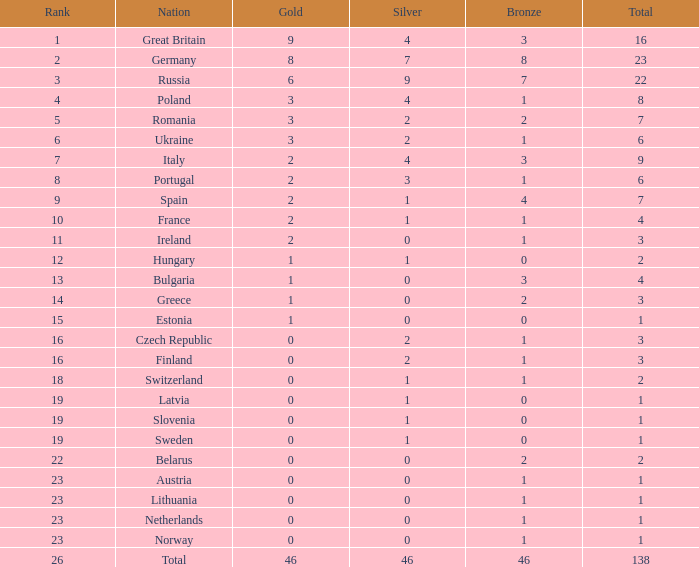Can you parse all the data within this table? {'header': ['Rank', 'Nation', 'Gold', 'Silver', 'Bronze', 'Total'], 'rows': [['1', 'Great Britain', '9', '4', '3', '16'], ['2', 'Germany', '8', '7', '8', '23'], ['3', 'Russia', '6', '9', '7', '22'], ['4', 'Poland', '3', '4', '1', '8'], ['5', 'Romania', '3', '2', '2', '7'], ['6', 'Ukraine', '3', '2', '1', '6'], ['7', 'Italy', '2', '4', '3', '9'], ['8', 'Portugal', '2', '3', '1', '6'], ['9', 'Spain', '2', '1', '4', '7'], ['10', 'France', '2', '1', '1', '4'], ['11', 'Ireland', '2', '0', '1', '3'], ['12', 'Hungary', '1', '1', '0', '2'], ['13', 'Bulgaria', '1', '0', '3', '4'], ['14', 'Greece', '1', '0', '2', '3'], ['15', 'Estonia', '1', '0', '0', '1'], ['16', 'Czech Republic', '0', '2', '1', '3'], ['16', 'Finland', '0', '2', '1', '3'], ['18', 'Switzerland', '0', '1', '1', '2'], ['19', 'Latvia', '0', '1', '0', '1'], ['19', 'Slovenia', '0', '1', '0', '1'], ['19', 'Sweden', '0', '1', '0', '1'], ['22', 'Belarus', '0', '0', '2', '2'], ['23', 'Austria', '0', '0', '1', '1'], ['23', 'Lithuania', '0', '0', '1', '1'], ['23', 'Netherlands', '0', '0', '1', '1'], ['23', 'Norway', '0', '0', '1', '1'], ['26', 'Total', '46', '46', '46', '138']]} What is the largest possible bronze when silver is more than 2, the nation is germany, and gold surpasses 8? None. 